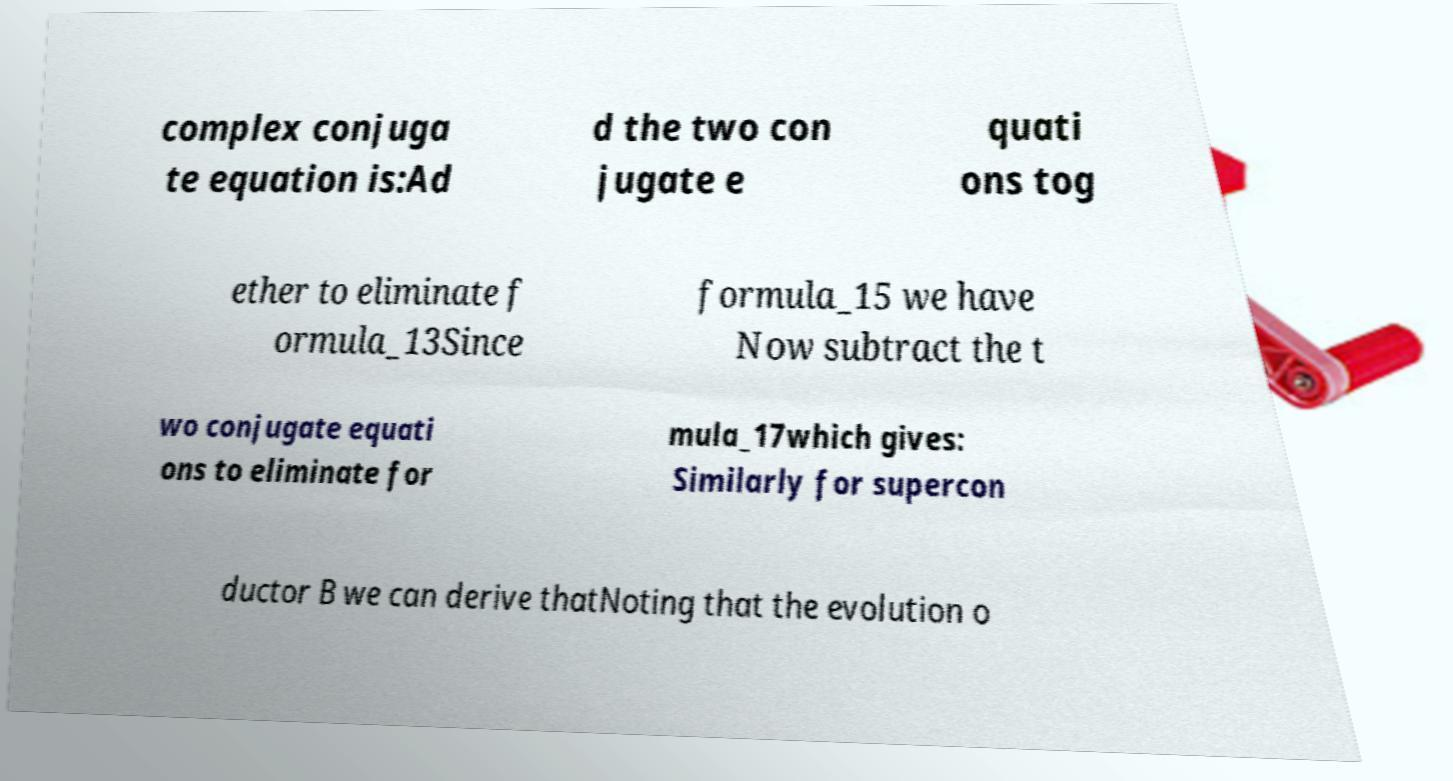I need the written content from this picture converted into text. Can you do that? complex conjuga te equation is:Ad d the two con jugate e quati ons tog ether to eliminate f ormula_13Since formula_15 we have Now subtract the t wo conjugate equati ons to eliminate for mula_17which gives: Similarly for supercon ductor B we can derive thatNoting that the evolution o 